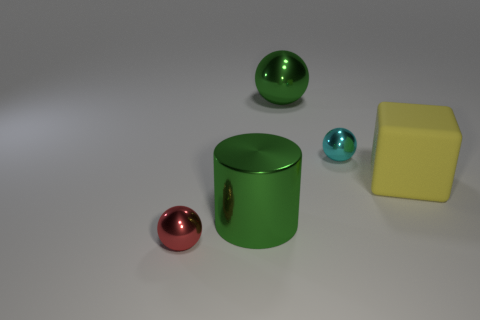How many large spheres have the same material as the large yellow thing?
Your response must be concise. 0. The big metal thing that is the same color as the big ball is what shape?
Your answer should be very brief. Cylinder. Is there a cyan shiny object that has the same shape as the large yellow object?
Give a very brief answer. No. There is a red shiny thing that is the same size as the cyan object; what shape is it?
Offer a terse response. Sphere. There is a large rubber block; is its color the same as the small shiny sphere that is left of the big metallic sphere?
Offer a terse response. No. What number of small cyan objects are on the right side of the tiny thing to the right of the small red object?
Offer a terse response. 0. What is the size of the metallic thing that is behind the small red shiny ball and in front of the big yellow cube?
Offer a very short reply. Large. Are there any metallic objects that have the same size as the green shiny cylinder?
Provide a succinct answer. Yes. Are there more big yellow matte objects on the left side of the small cyan metal object than metal things that are in front of the yellow cube?
Your response must be concise. No. Is the material of the green ball the same as the cylinder that is on the left side of the cyan thing?
Your response must be concise. Yes. 